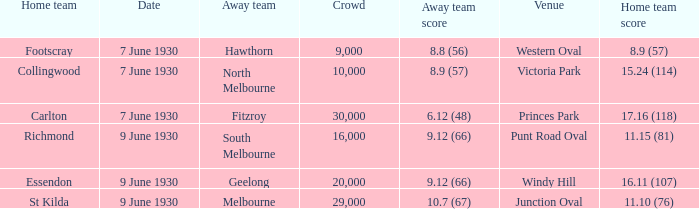At windy hill, which team scored 9.12 (66) while playing away? Geelong. 